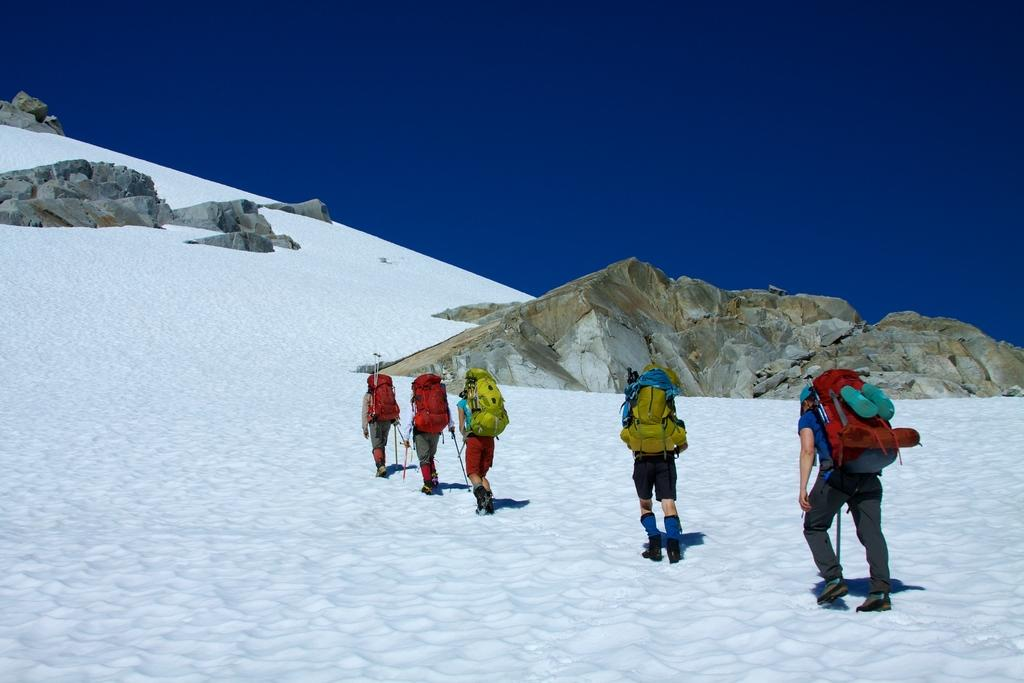What type of animal is in the image? There is a sow in the image. What else can be seen in the image besides the sow? There are rocks and the sky visible in the image. Are there any human activities depicted in the image? Yes, there are people walking in the image. What type of income can be seen in the image? There is no income visible in the image; it features a sow, rocks, the sky, and people walking. How does the beast interact with the sow in the image? There is no beast present in the image, only a sow. 